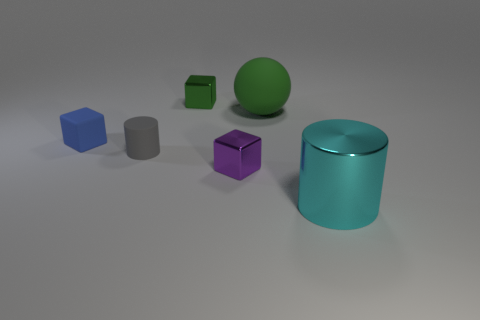What materials are the objects in the image made of, and how can you tell? The objects in the image appear to be made of different materials. The blue and green cubes, as well as the round green object, have a matte surface indicating that they could be made of rubber. The purple cube and the teal cylinder have a reflective surface, which suggests they might be made of plastic or metal, as these materials typically have higher shininess. 